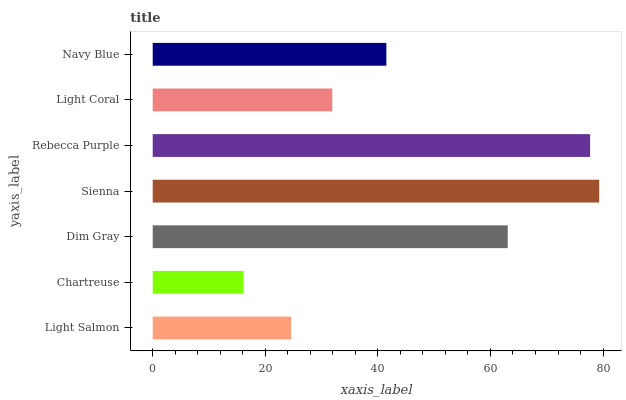Is Chartreuse the minimum?
Answer yes or no. Yes. Is Sienna the maximum?
Answer yes or no. Yes. Is Dim Gray the minimum?
Answer yes or no. No. Is Dim Gray the maximum?
Answer yes or no. No. Is Dim Gray greater than Chartreuse?
Answer yes or no. Yes. Is Chartreuse less than Dim Gray?
Answer yes or no. Yes. Is Chartreuse greater than Dim Gray?
Answer yes or no. No. Is Dim Gray less than Chartreuse?
Answer yes or no. No. Is Navy Blue the high median?
Answer yes or no. Yes. Is Navy Blue the low median?
Answer yes or no. Yes. Is Rebecca Purple the high median?
Answer yes or no. No. Is Light Coral the low median?
Answer yes or no. No. 